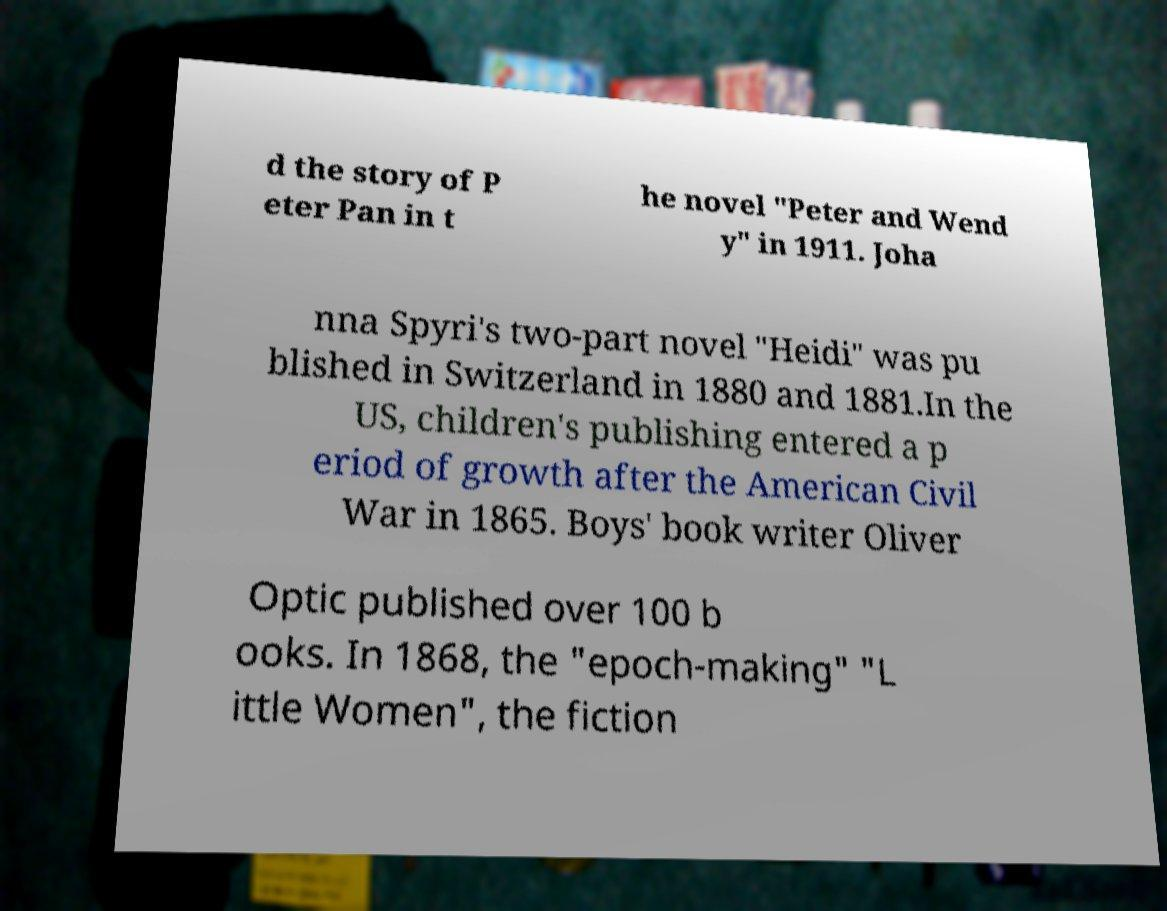I need the written content from this picture converted into text. Can you do that? d the story of P eter Pan in t he novel "Peter and Wend y" in 1911. Joha nna Spyri's two-part novel "Heidi" was pu blished in Switzerland in 1880 and 1881.In the US, children's publishing entered a p eriod of growth after the American Civil War in 1865. Boys' book writer Oliver Optic published over 100 b ooks. In 1868, the "epoch-making" "L ittle Women", the fiction 